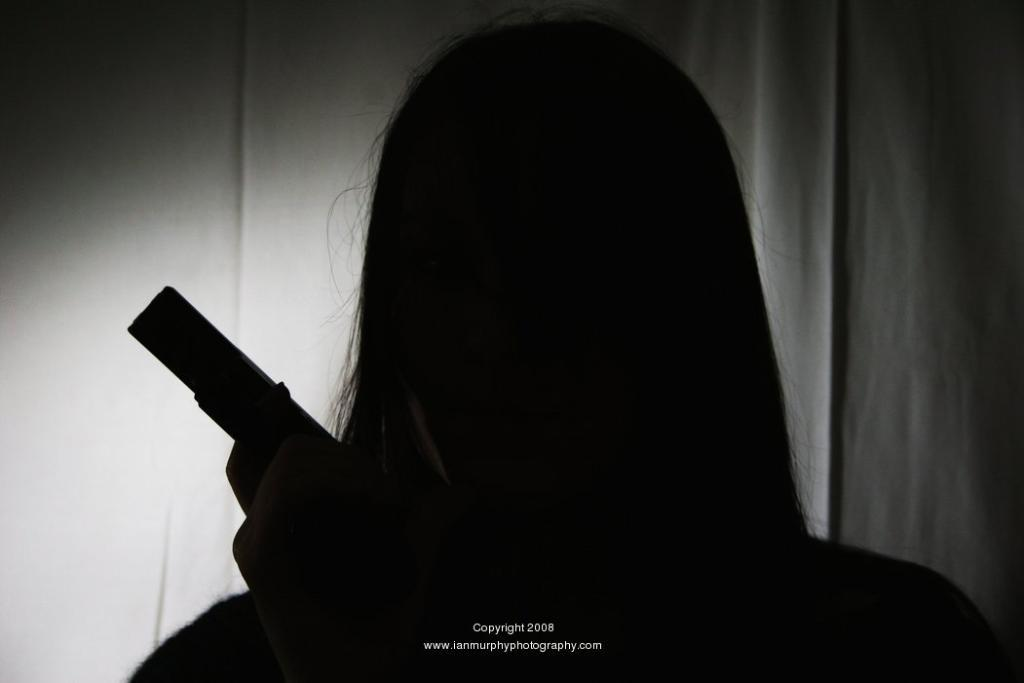What is the color scheme of the image? The image is black and white. What can be seen in the image besides the color scheme? There is a shadow of a woman in the image. What is the woman doing in the image? The woman is holding an object. What additional information is provided at the bottom of the image? There is text at the bottom of the image. Can you see any wounds on the woman's fingers in the image? There are no visible fingers or wounds in the image, as it only shows a shadow of a woman holding an object. 